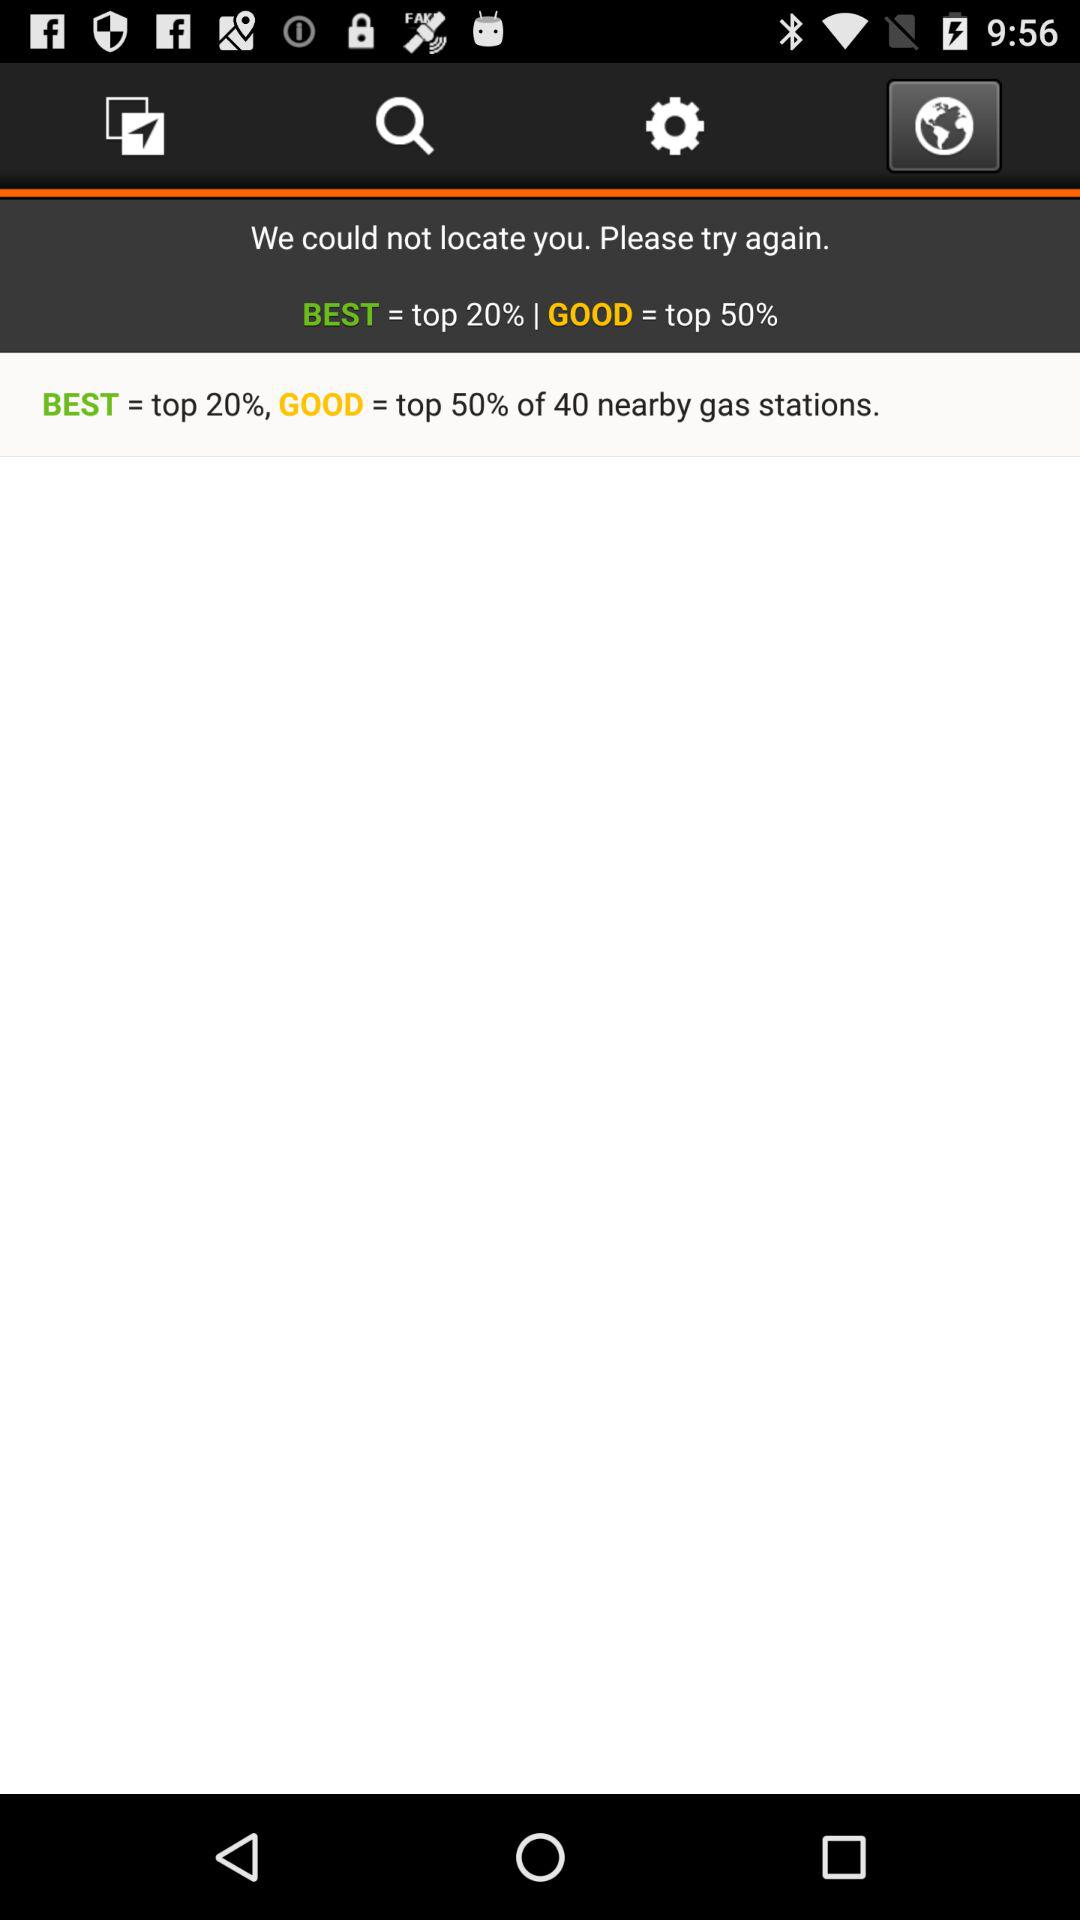What is the "BEST" equivalent to? The "BEST" is equivalent to the top 20%. 